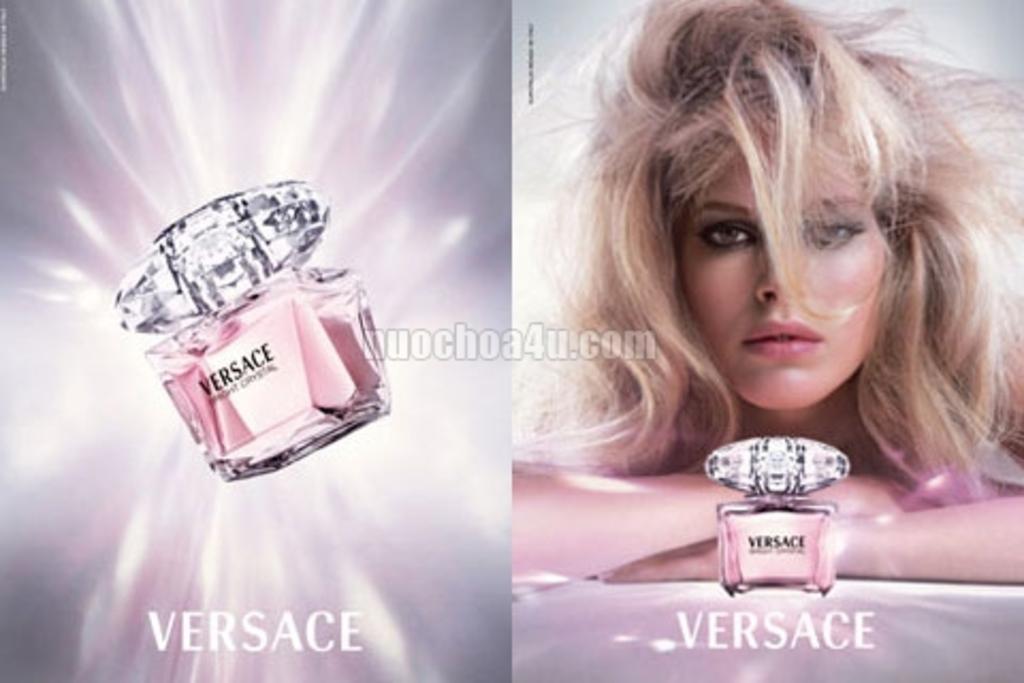Who makes this brand of expensive perfume?
Your answer should be compact. Versace. 